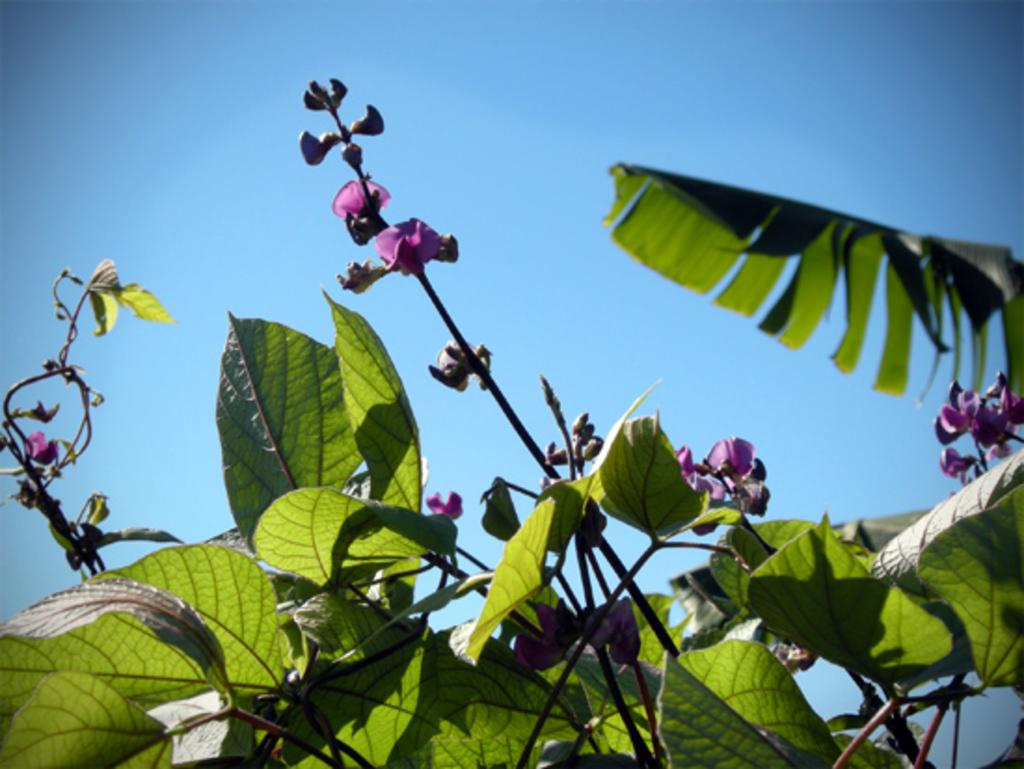What is located in the center of the image? There are flowers and trees in the center of the image. Can you describe the background of the image? The sky is visible in the background of the image. What type of property can be seen in the image? There is no property visible in the image; it features flowers, trees, and the sky. How many snakes are slithering through the flowers in the image? There are no snakes present in the image. 